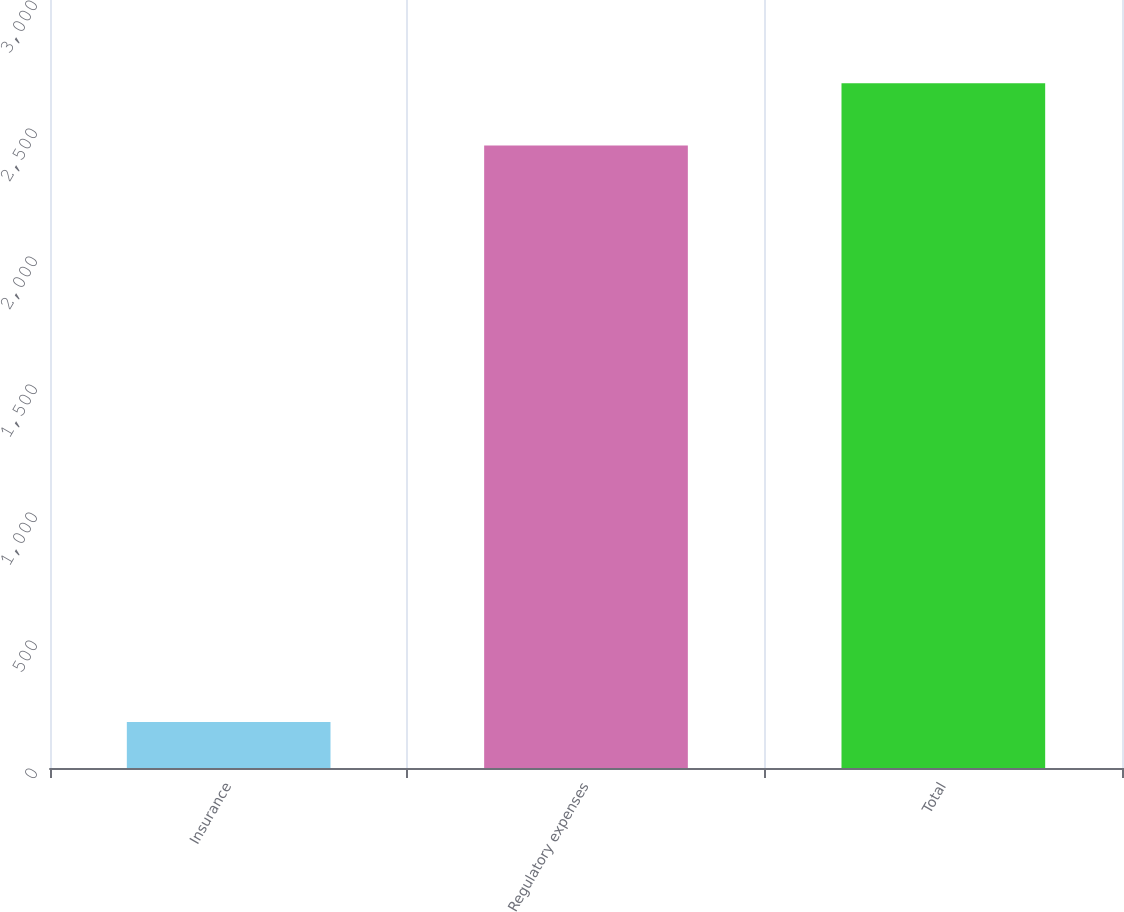Convert chart to OTSL. <chart><loc_0><loc_0><loc_500><loc_500><bar_chart><fcel>Insurance<fcel>Regulatory expenses<fcel>Total<nl><fcel>180<fcel>2432<fcel>2675.2<nl></chart> 